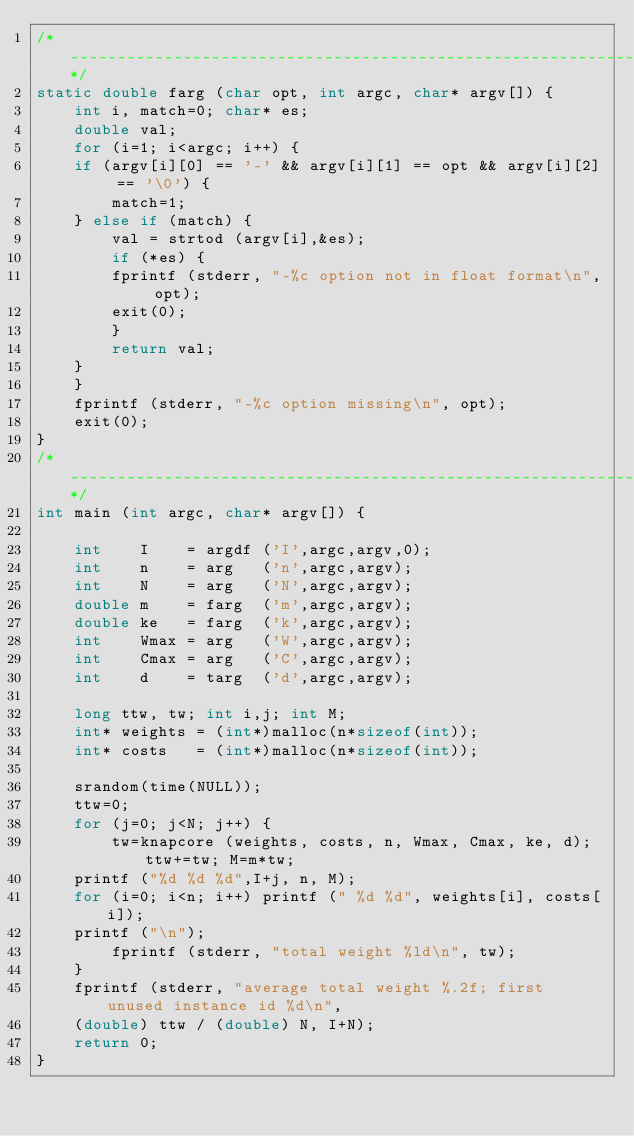<code> <loc_0><loc_0><loc_500><loc_500><_C_>/*-----------------------------------------------------------------------------*/
static double farg (char opt, int argc, char* argv[]) {
    int i, match=0; char* es;
    double val;
    for (i=1; i<argc; i++) {
	if (argv[i][0] == '-' && argv[i][1] == opt && argv[i][2] == '\0') {
	    match=1;
	} else if (match) {
	    val = strtod (argv[i],&es);
	    if (*es) {
		fprintf (stderr, "-%c option not in float format\n", opt);
		exit(0);
	    }
	    return val;
	}
    }
    fprintf (stderr, "-%c option missing\n", opt);
    exit(0);
}
/*-----------------------------------------------------------------------------*/
int main (int argc, char* argv[]) {

    int    I 	= argdf ('I',argc,argv,0);
    int    n 	= arg   ('n',argc,argv);
    int    N 	= arg   ('N',argc,argv);
    double m 	= farg  ('m',argc,argv);
    double ke 	= farg  ('k',argc,argv);
    int    Wmax = arg   ('W',argc,argv);
    int    Cmax = arg   ('C',argc,argv);
    int    d    = targ  ('d',argc,argv);

    long ttw, tw; int i,j; int M;
    int* weights = (int*)malloc(n*sizeof(int));
    int* costs   = (int*)malloc(n*sizeof(int));

    srandom(time(NULL));
    ttw=0;
    for (j=0; j<N; j++) {
        tw=knapcore (weights, costs, n, Wmax, Cmax, ke, d); ttw+=tw; M=m*tw;
	printf ("%d %d %d",I+j, n, M);
	for (i=0; i<n; i++) printf (" %d %d", weights[i], costs[i]);
	printf ("\n");
        fprintf (stderr, "total weight %ld\n", tw);
    }
    fprintf (stderr, "average total weight %.2f; first unused instance id %d\n",
	(double) ttw / (double) N, I+N);
    return 0;
}

</code> 